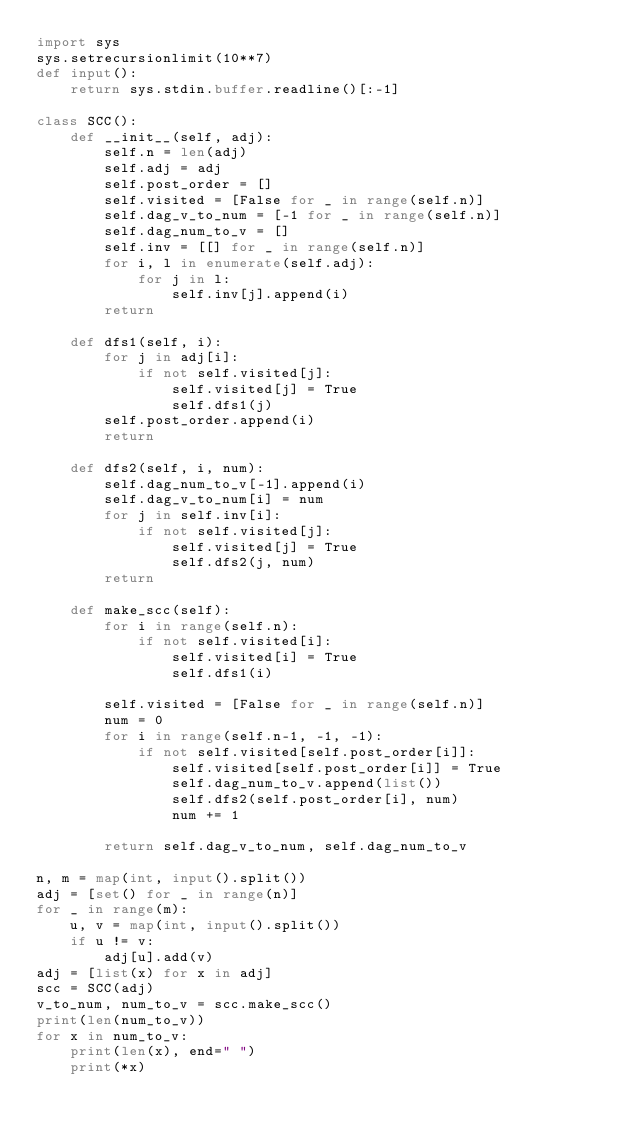Convert code to text. <code><loc_0><loc_0><loc_500><loc_500><_Python_>import sys
sys.setrecursionlimit(10**7)
def input():
	return sys.stdin.buffer.readline()[:-1]

class SCC():
	def __init__(self, adj):
		self.n = len(adj)
		self.adj = adj
		self.post_order = []
		self.visited = [False for _ in range(self.n)]
		self.dag_v_to_num = [-1 for _ in range(self.n)]
		self.dag_num_to_v = []
		self.inv = [[] for _ in range(self.n)]
		for i, l in enumerate(self.adj):
			for j in l:
				self.inv[j].append(i)
		return

	def dfs1(self, i):
		for j in adj[i]:
			if not self.visited[j]:
				self.visited[j] = True
				self.dfs1(j)
		self.post_order.append(i)
		return

	def dfs2(self, i, num):
		self.dag_num_to_v[-1].append(i)
		self.dag_v_to_num[i] = num
		for j in self.inv[i]:
			if not self.visited[j]:
				self.visited[j] = True
				self.dfs2(j, num)
		return

	def make_scc(self):
		for i in range(self.n):
			if not self.visited[i]:
				self.visited[i] = True
				self.dfs1(i)

		self.visited = [False for _ in range(self.n)]
		num = 0
		for i in range(self.n-1, -1, -1):
			if not self.visited[self.post_order[i]]:
				self.visited[self.post_order[i]] = True
				self.dag_num_to_v.append(list())
				self.dfs2(self.post_order[i], num)
				num += 1

		return self.dag_v_to_num, self.dag_num_to_v

n, m = map(int, input().split())
adj = [set() for _ in range(n)]
for _ in range(m):
	u, v = map(int, input().split())
	if u != v:
		adj[u].add(v)
adj = [list(x) for x in adj]
scc = SCC(adj)
v_to_num, num_to_v = scc.make_scc()
print(len(num_to_v))
for x in num_to_v:
	print(len(x), end=" ")
	print(*x)</code> 